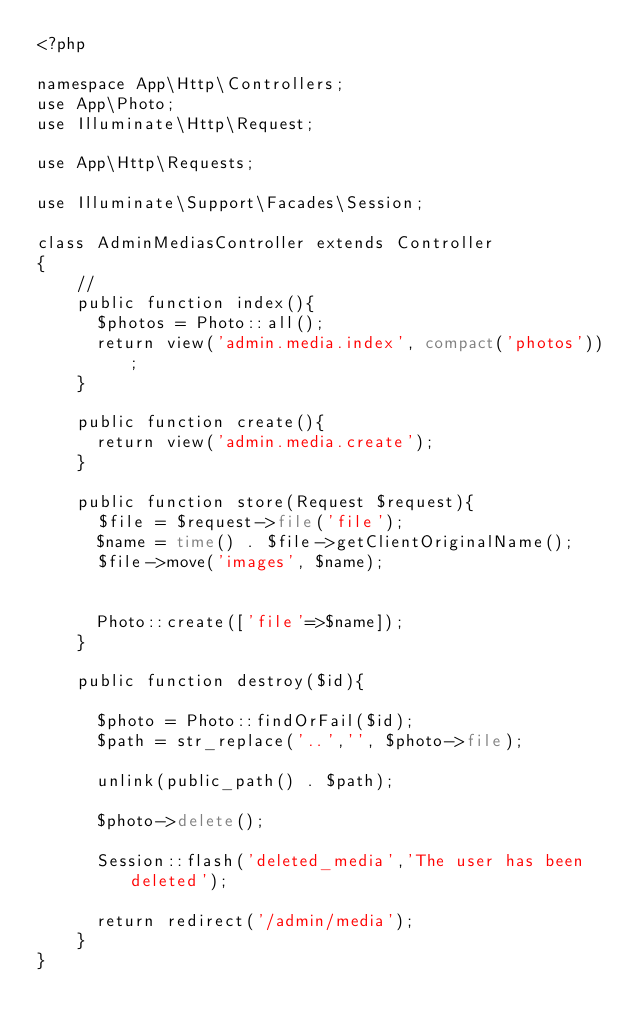<code> <loc_0><loc_0><loc_500><loc_500><_PHP_><?php

namespace App\Http\Controllers;
use App\Photo;
use Illuminate\Http\Request;

use App\Http\Requests;

use Illuminate\Support\Facades\Session;

class AdminMediasController extends Controller
{
    //
    public function index(){
    	$photos = Photo::all();
    	return view('admin.media.index', compact('photos'));
    }

    public function create(){
    	return view('admin.media.create');
    }

    public function store(Request $request){
    	$file = $request->file('file');
    	$name = time() . $file->getClientOriginalName();
    	$file->move('images', $name);


    	Photo::create(['file'=>$name]);
    }

    public function destroy($id){

    	$photo = Photo::findOrFail($id);
    	$path = str_replace('..','', $photo->file);

    	unlink(public_path() . $path);

    	$photo->delete();

    	Session::flash('deleted_media','The user has been deleted');

    	return redirect('/admin/media');
    }
}
</code> 